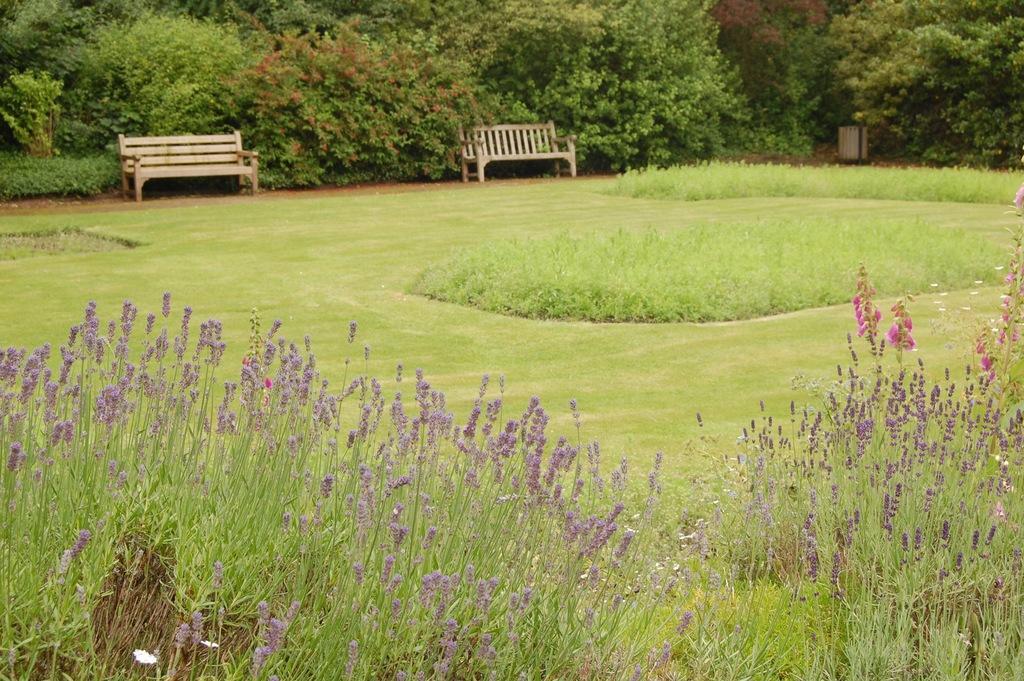Can you describe this image briefly? At the bottom we can see plants. In the background we can see grass,two benches on the ground,trees and an object on the right side. 